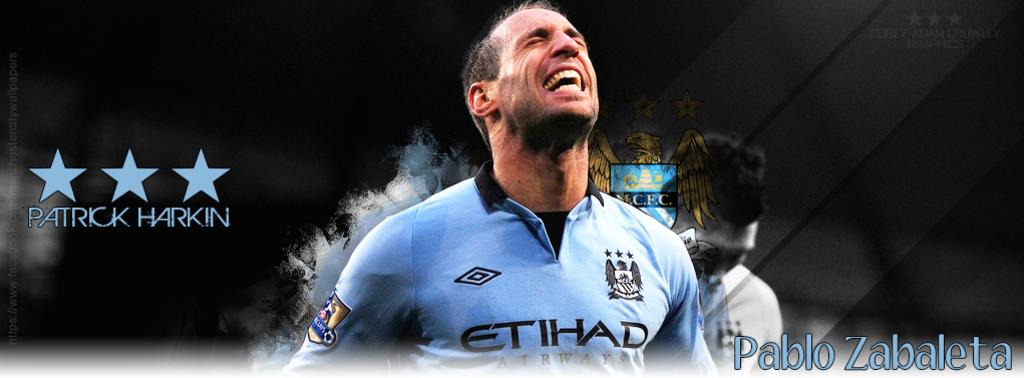Who is the featured player?
Provide a succinct answer. Patrick harkin. What name is listed under the three stars?
Keep it short and to the point. Patrick harkin. 